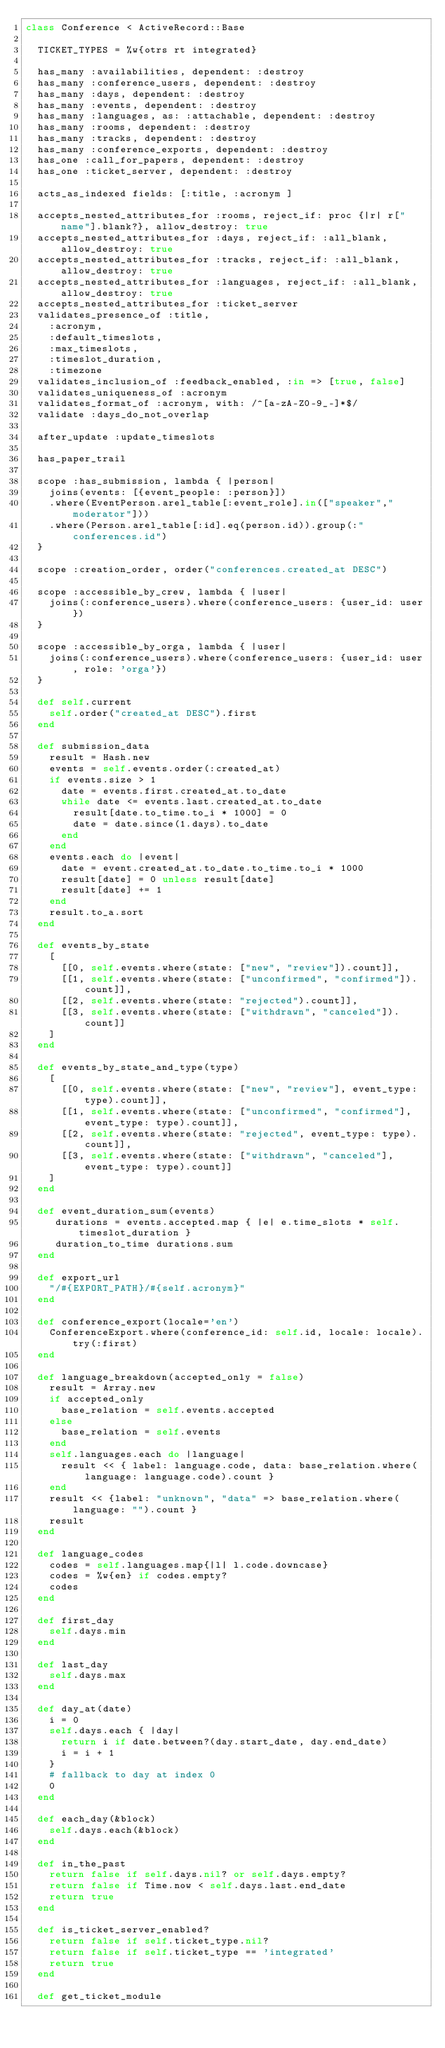Convert code to text. <code><loc_0><loc_0><loc_500><loc_500><_Ruby_>class Conference < ActiveRecord::Base

  TICKET_TYPES = %w{otrs rt integrated}

  has_many :availabilities, dependent: :destroy
  has_many :conference_users, dependent: :destroy
  has_many :days, dependent: :destroy
  has_many :events, dependent: :destroy
  has_many :languages, as: :attachable, dependent: :destroy
  has_many :rooms, dependent: :destroy
  has_many :tracks, dependent: :destroy
  has_many :conference_exports, dependent: :destroy
  has_one :call_for_papers, dependent: :destroy
  has_one :ticket_server, dependent: :destroy

  acts_as_indexed fields: [:title, :acronym ]

  accepts_nested_attributes_for :rooms, reject_if: proc {|r| r["name"].blank?}, allow_destroy: true
  accepts_nested_attributes_for :days, reject_if: :all_blank, allow_destroy: true
  accepts_nested_attributes_for :tracks, reject_if: :all_blank, allow_destroy: true
  accepts_nested_attributes_for :languages, reject_if: :all_blank, allow_destroy: true
  accepts_nested_attributes_for :ticket_server
  validates_presence_of :title, 
    :acronym, 
    :default_timeslots,
    :max_timeslots,
    :timeslot_duration,
    :timezone
  validates_inclusion_of :feedback_enabled, :in => [true, false]
  validates_uniqueness_of :acronym
  validates_format_of :acronym, with: /^[a-zA-Z0-9_-]*$/
  validate :days_do_not_overlap

  after_update :update_timeslots

  has_paper_trail 

  scope :has_submission, lambda { |person|
    joins(events: [{event_people: :person}])
    .where(EventPerson.arel_table[:event_role].in(["speaker","moderator"]))
    .where(Person.arel_table[:id].eq(person.id)).group(:"conferences.id")
  }

  scope :creation_order, order("conferences.created_at DESC")

  scope :accessible_by_crew, lambda { |user| 
    joins(:conference_users).where(conference_users: {user_id: user})
  }

  scope :accessible_by_orga, lambda { |user| 
    joins(:conference_users).where(conference_users: {user_id: user, role: 'orga'})
  }

  def self.current
    self.order("created_at DESC").first
  end

  def submission_data
    result = Hash.new
    events = self.events.order(:created_at)
    if events.size > 1
      date = events.first.created_at.to_date
      while date <= events.last.created_at.to_date
        result[date.to_time.to_i * 1000] = 0
        date = date.since(1.days).to_date
      end
    end
    events.each do |event|
      date = event.created_at.to_date.to_time.to_i * 1000
      result[date] = 0 unless result[date]
      result[date] += 1
    end
    result.to_a.sort
  end

  def events_by_state
    [
      [[0, self.events.where(state: ["new", "review"]).count]],
      [[1, self.events.where(state: ["unconfirmed", "confirmed"]).count]],
      [[2, self.events.where(state: "rejected").count]],
      [[3, self.events.where(state: ["withdrawn", "canceled"]).count]]
    ]
  end

  def events_by_state_and_type(type)
    [
      [[0, self.events.where(state: ["new", "review"], event_type: type).count]],
      [[1, self.events.where(state: ["unconfirmed", "confirmed"], event_type: type).count]],
      [[2, self.events.where(state: "rejected", event_type: type).count]],
      [[3, self.events.where(state: ["withdrawn", "canceled"], event_type: type).count]]
    ]
  end

  def event_duration_sum(events)
     durations = events.accepted.map { |e| e.time_slots * self.timeslot_duration }
     duration_to_time durations.sum
  end

  def export_url
    "/#{EXPORT_PATH}/#{self.acronym}"
  end

  def conference_export(locale='en')
    ConferenceExport.where(conference_id: self.id, locale: locale).try(:first)
  end

  def language_breakdown(accepted_only = false)
    result = Array.new
    if accepted_only
      base_relation = self.events.accepted
    else
      base_relation = self.events
    end
    self.languages.each do |language|
      result << { label: language.code, data: base_relation.where(language: language.code).count }
    end
    result << {label: "unknown", "data" => base_relation.where(language: "").count }
    result
  end

  def language_codes
    codes = self.languages.map{|l| l.code.downcase}
    codes = %w{en} if codes.empty?
    codes
  end

  def first_day
    self.days.min
  end

  def last_day
    self.days.max
  end

  def day_at(date)
    i = 0
    self.days.each { |day|
      return i if date.between?(day.start_date, day.end_date)
      i = i + 1
    }
    # fallback to day at index 0
    0
  end

  def each_day(&block)
    self.days.each(&block)
  end

  def in_the_past
    return false if self.days.nil? or self.days.empty?
    return false if Time.now < self.days.last.end_date
    return true
  end

  def is_ticket_server_enabled?
    return false if self.ticket_type.nil?
    return false if self.ticket_type == 'integrated'
    return true
  end

  def get_ticket_module</code> 